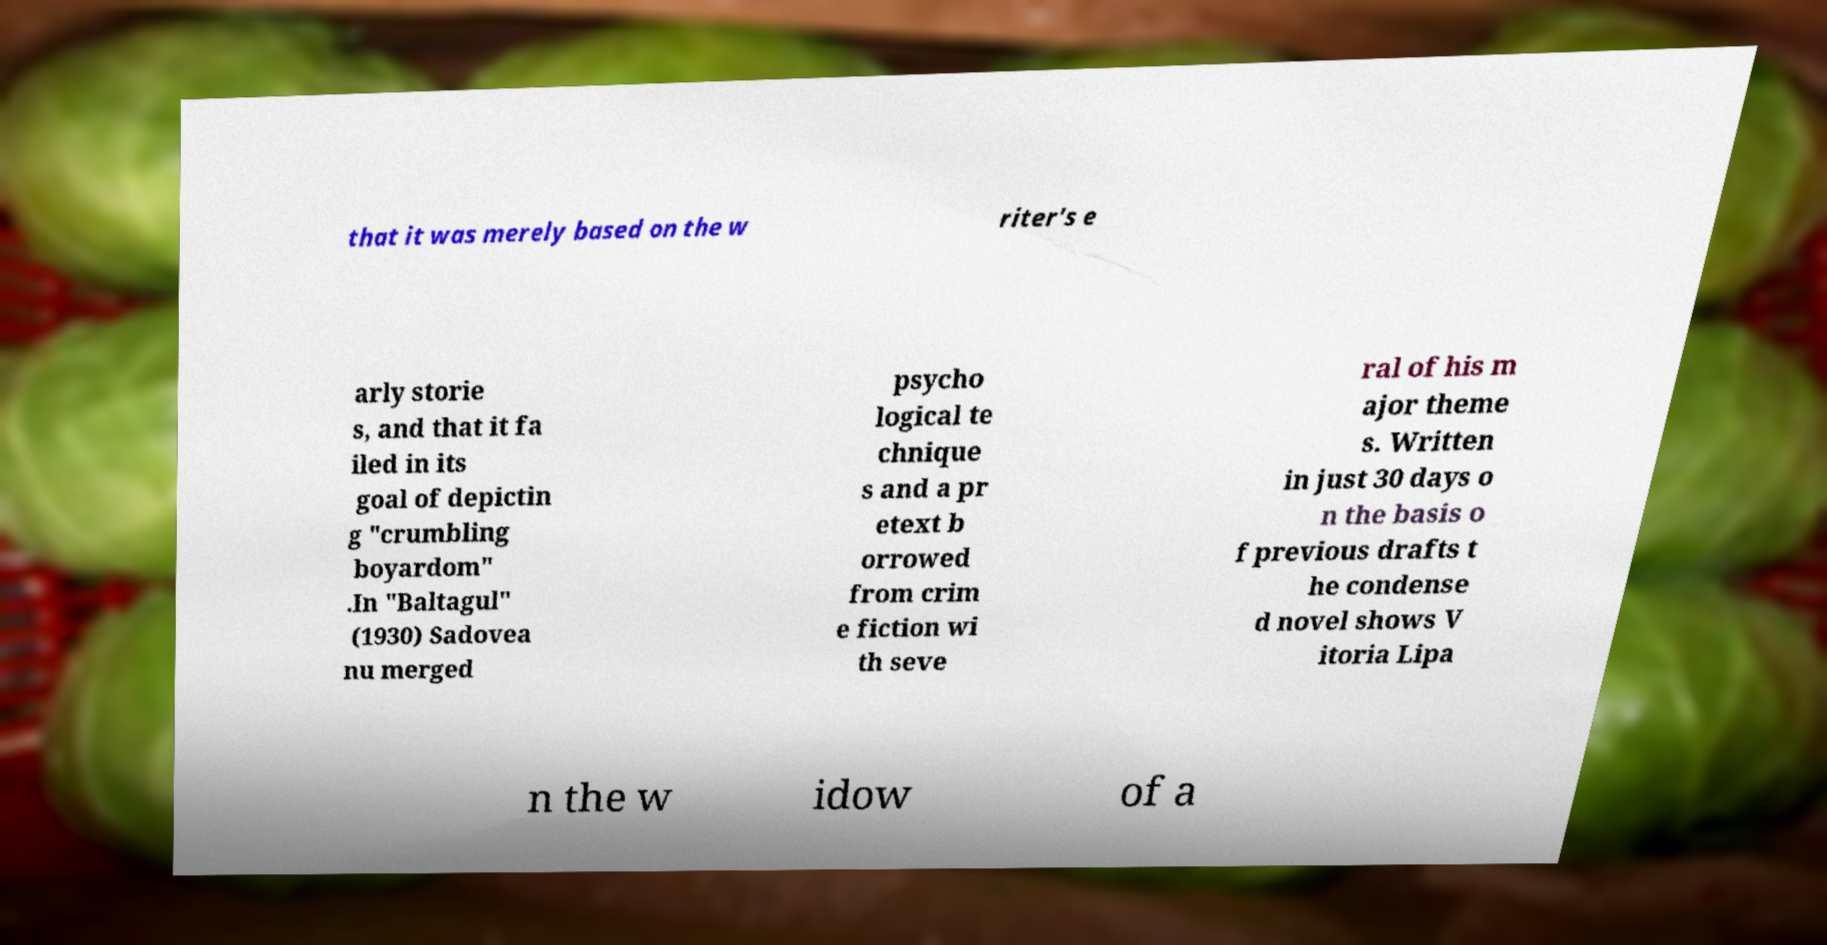For documentation purposes, I need the text within this image transcribed. Could you provide that? that it was merely based on the w riter's e arly storie s, and that it fa iled in its goal of depictin g "crumbling boyardom" .In "Baltagul" (1930) Sadovea nu merged psycho logical te chnique s and a pr etext b orrowed from crim e fiction wi th seve ral of his m ajor theme s. Written in just 30 days o n the basis o f previous drafts t he condense d novel shows V itoria Lipa n the w idow of a 